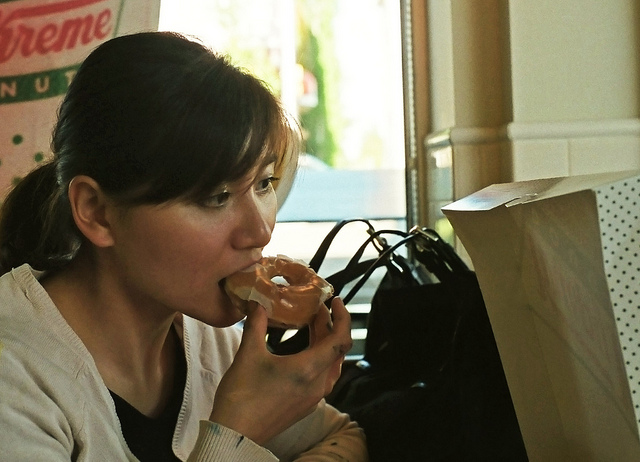<image>Which wrist has a bracelet? It is unknown which wrist has a bracelet. It could be either the left or the right wrist, or neither. Which wrist has a bracelet? It is unknown which wrist has a bracelet. Neither left nor right wrist is seen with a bracelet. 